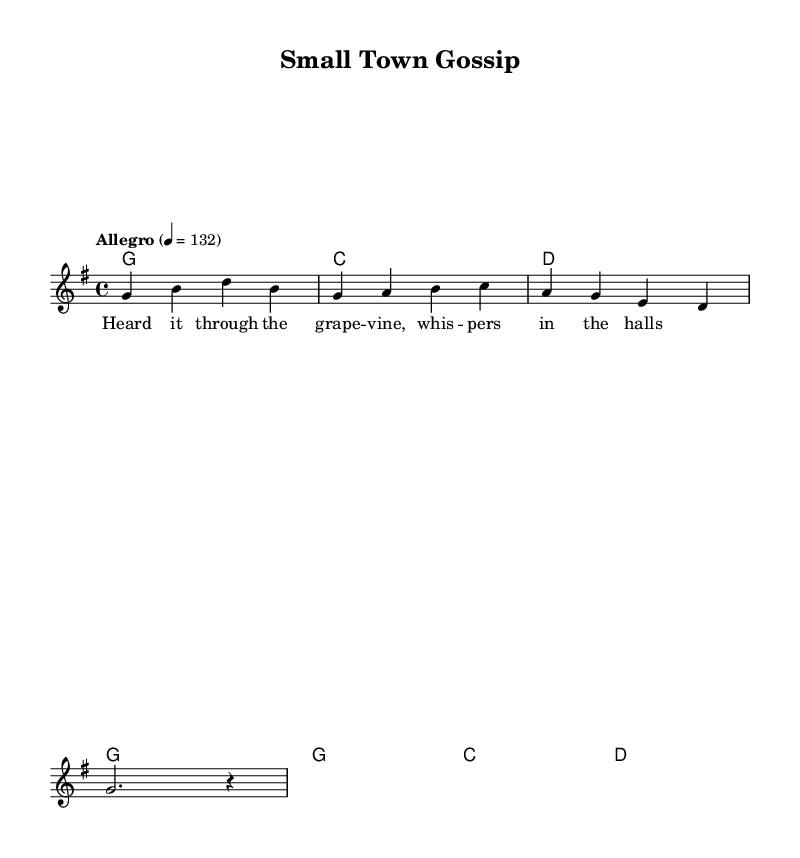What is the key signature of this music? The key signature is G major, which has one sharp (F#). You can tell by looking at the key signature at the beginning of the staff, which indicates G major.
Answer: G major What is the time signature of this music? The time signature is 4/4, which means there are four beats in each measure and the quarter note gets one beat. This can be found at the beginning of the sheet music next to the key signature.
Answer: 4/4 What is the tempo marking for this piece? The tempo marking indicates "Allegro" at a speed of 132 beats per minute. This is stated at the beginning of the score, giving a guide on how fast to play the music.
Answer: Allegro 4 = 132 What chord is played in the first measure? The first chord played is G major, as indicated by the chord name and the notes in the corresponding measure. It is shown at the beginning of the first measure.
Answer: G What style of music does this piece represent? This piece represents country music, identifiable by its upbeat rhythm and thematic focus on small-town life, which is reflected in the lyrics and melodies typical of the genre.
Answer: Country How many measures are in the score? The score contains a total of four measures. Counting each bar line in the music indicates the number of measures present in the piece.
Answer: Four Which lyrical theme is introduced in this piece? The lyrical theme introduces gossip about small-town happenings, as suggested by the lyrics that mention "whispers in the halls." This aligns with common themes in country music.
Answer: Gossip 